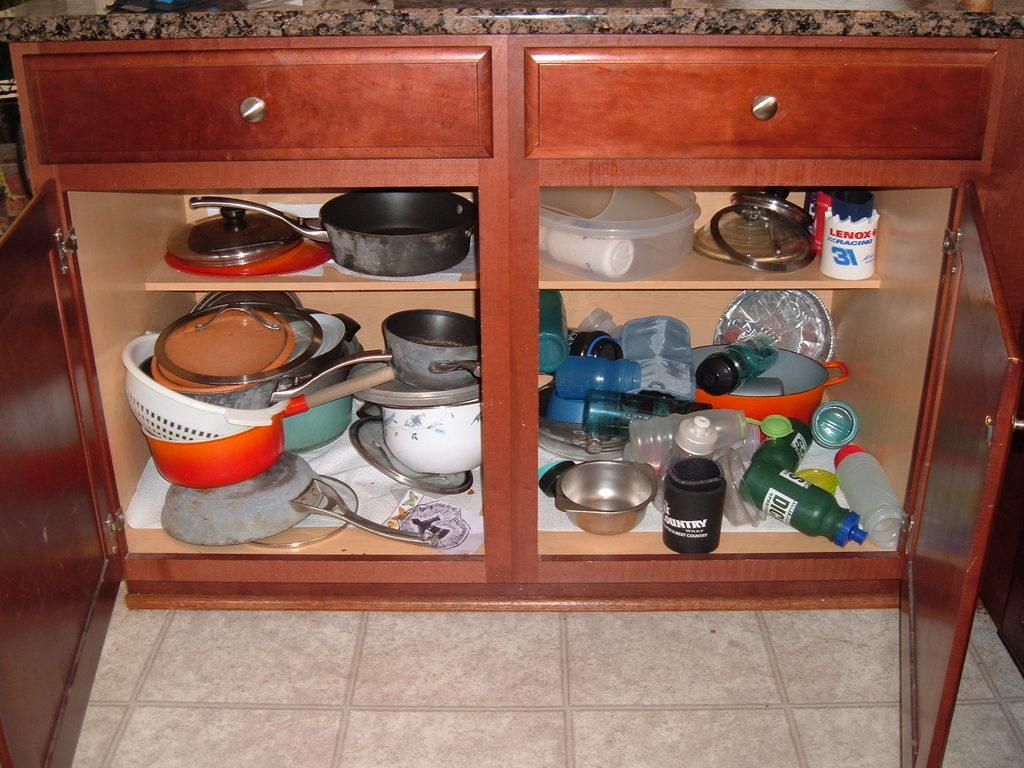What is the main object in the image? There is a marble in the image. What is located at the bottom of the image? There is a cupboard at the bottom of the image. What types of items can be found inside the cupboard? There are bottles, a pan, a bowl, a box, a paper, and plates, as well as a few other objects in the cupboard. What type of hair can be seen on the marble in the image? There is no hair present on the marble in the image. What day of the week is depicted in the image? The image does not depict a specific day of the week. 